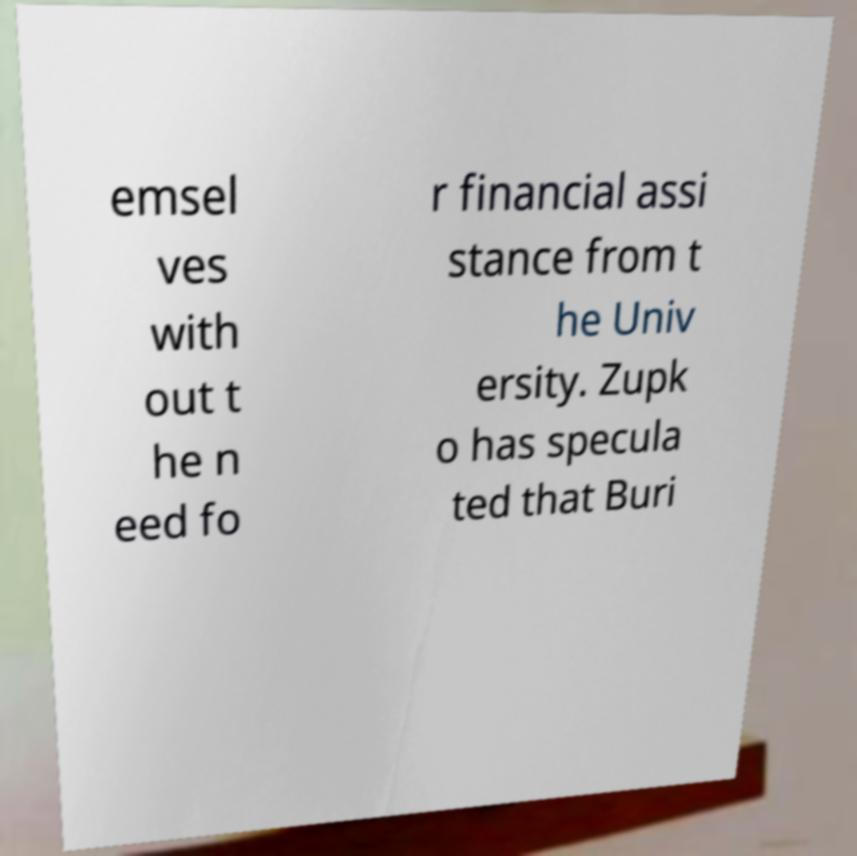For documentation purposes, I need the text within this image transcribed. Could you provide that? emsel ves with out t he n eed fo r financial assi stance from t he Univ ersity. Zupk o has specula ted that Buri 